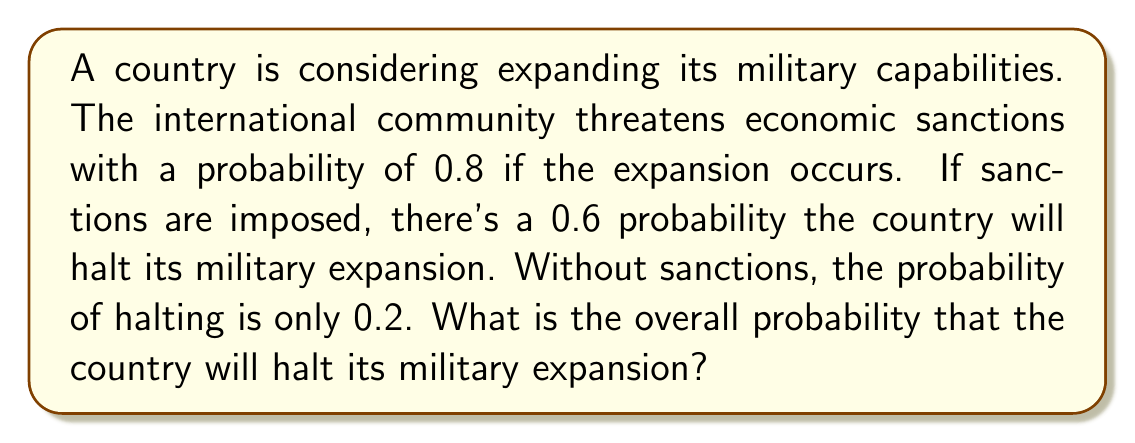Help me with this question. Let's approach this step-by-step using the law of total probability:

1) Define events:
   S: Sanctions are imposed
   H: Country halts military expansion

2) Given probabilities:
   P(S) = 0.8
   P(H|S) = 0.6 (probability of halting given sanctions)
   P(H|not S) = 0.2 (probability of halting without sanctions)

3) Law of Total Probability:
   P(H) = P(H|S) * P(S) + P(H|not S) * P(not S)

4) Calculate P(not S):
   P(not S) = 1 - P(S) = 1 - 0.8 = 0.2

5) Plug into the formula:
   P(H) = 0.6 * 0.8 + 0.2 * 0.2

6) Calculate:
   P(H) = 0.48 + 0.04 = 0.52

Therefore, the overall probability that the country will halt its military expansion is 0.52 or 52%.
Answer: 0.52 